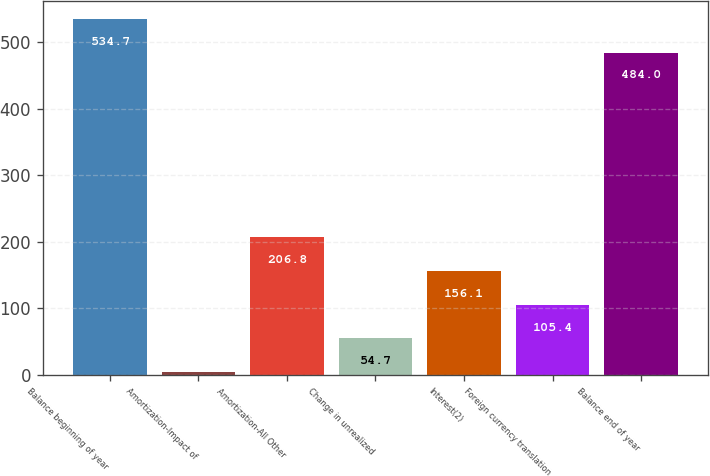Convert chart. <chart><loc_0><loc_0><loc_500><loc_500><bar_chart><fcel>Balance beginning of year<fcel>Amortization-Impact of<fcel>Amortization-All Other<fcel>Change in unrealized<fcel>Interest(2)<fcel>Foreign currency translation<fcel>Balance end of year<nl><fcel>534.7<fcel>4<fcel>206.8<fcel>54.7<fcel>156.1<fcel>105.4<fcel>484<nl></chart> 